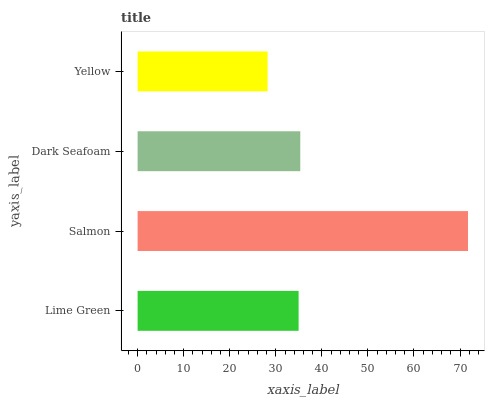Is Yellow the minimum?
Answer yes or no. Yes. Is Salmon the maximum?
Answer yes or no. Yes. Is Dark Seafoam the minimum?
Answer yes or no. No. Is Dark Seafoam the maximum?
Answer yes or no. No. Is Salmon greater than Dark Seafoam?
Answer yes or no. Yes. Is Dark Seafoam less than Salmon?
Answer yes or no. Yes. Is Dark Seafoam greater than Salmon?
Answer yes or no. No. Is Salmon less than Dark Seafoam?
Answer yes or no. No. Is Dark Seafoam the high median?
Answer yes or no. Yes. Is Lime Green the low median?
Answer yes or no. Yes. Is Yellow the high median?
Answer yes or no. No. Is Salmon the low median?
Answer yes or no. No. 